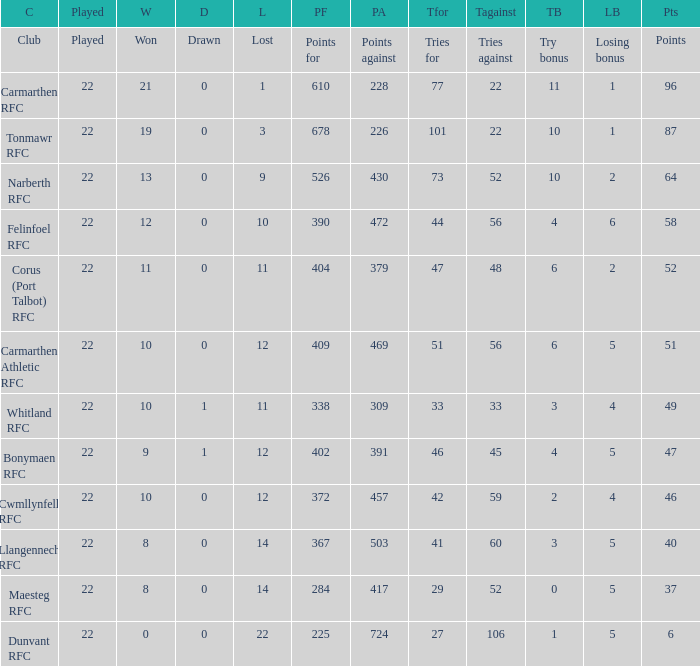Name the losing bonus for 27 5.0. 